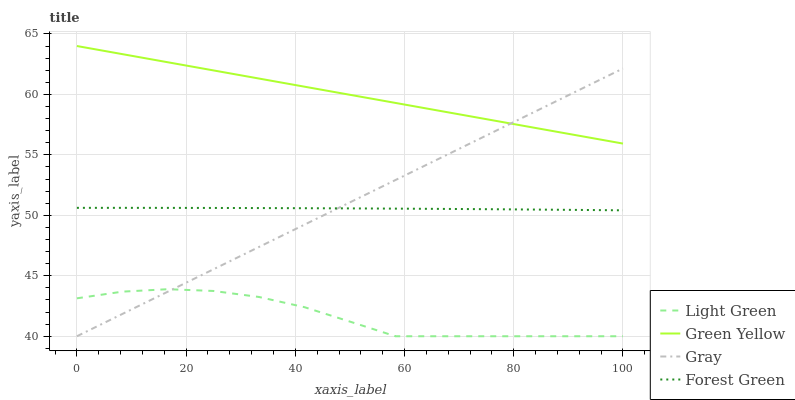Does Light Green have the minimum area under the curve?
Answer yes or no. Yes. Does Green Yellow have the maximum area under the curve?
Answer yes or no. Yes. Does Forest Green have the minimum area under the curve?
Answer yes or no. No. Does Forest Green have the maximum area under the curve?
Answer yes or no. No. Is Green Yellow the smoothest?
Answer yes or no. Yes. Is Light Green the roughest?
Answer yes or no. Yes. Is Forest Green the smoothest?
Answer yes or no. No. Is Forest Green the roughest?
Answer yes or no. No. Does Gray have the lowest value?
Answer yes or no. Yes. Does Forest Green have the lowest value?
Answer yes or no. No. Does Green Yellow have the highest value?
Answer yes or no. Yes. Does Forest Green have the highest value?
Answer yes or no. No. Is Light Green less than Forest Green?
Answer yes or no. Yes. Is Green Yellow greater than Forest Green?
Answer yes or no. Yes. Does Gray intersect Green Yellow?
Answer yes or no. Yes. Is Gray less than Green Yellow?
Answer yes or no. No. Is Gray greater than Green Yellow?
Answer yes or no. No. Does Light Green intersect Forest Green?
Answer yes or no. No. 